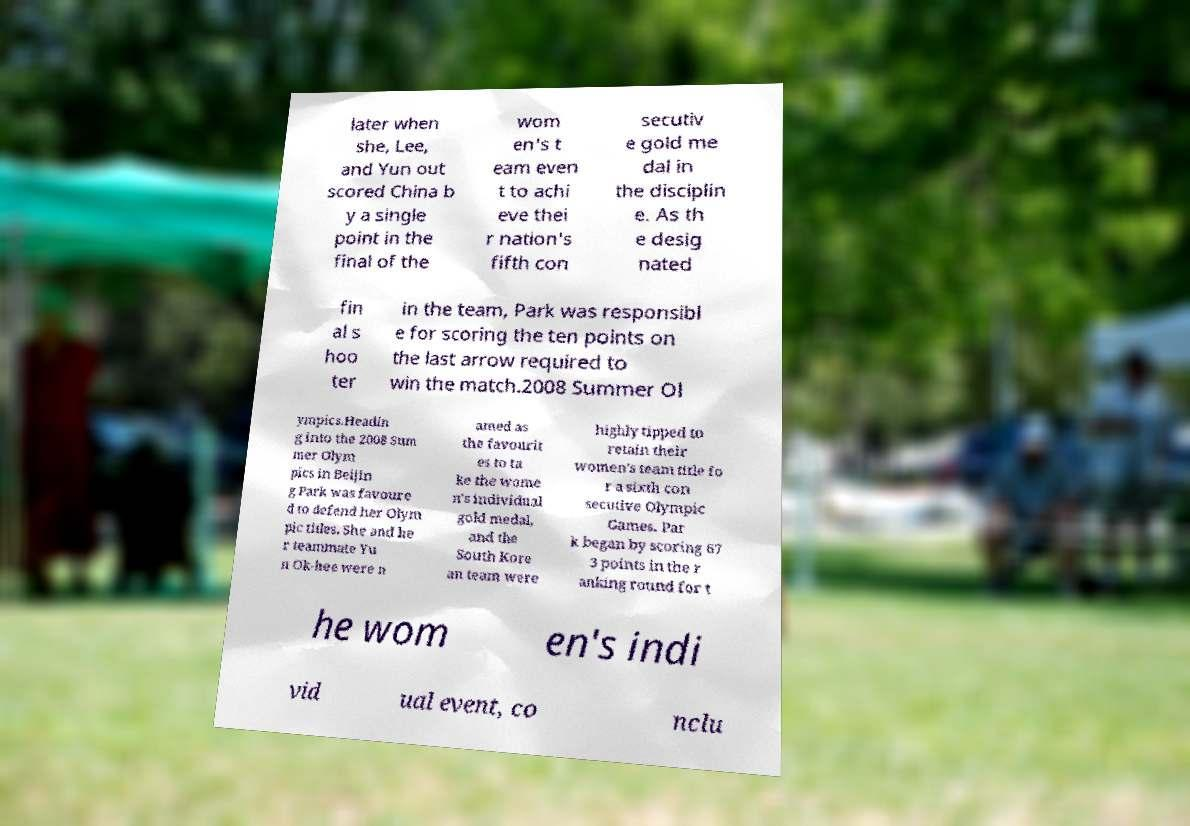Could you extract and type out the text from this image? later when she, Lee, and Yun out scored China b y a single point in the final of the wom en's t eam even t to achi eve thei r nation's fifth con secutiv e gold me dal in the disciplin e. As th e desig nated fin al s hoo ter in the team, Park was responsibl e for scoring the ten points on the last arrow required to win the match.2008 Summer Ol ympics.Headin g into the 2008 Sum mer Olym pics in Beijin g Park was favoure d to defend her Olym pic titles. She and he r teammate Yu n Ok-hee were n amed as the favourit es to ta ke the wome n's individual gold medal, and the South Kore an team were highly tipped to retain their women's team title fo r a sixth con secutive Olympic Games. Par k began by scoring 67 3 points in the r anking round for t he wom en's indi vid ual event, co nclu 